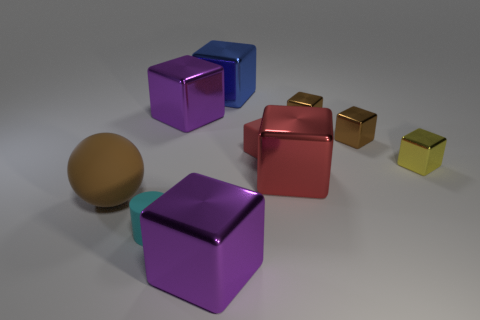What is the material of the large red thing that is the same shape as the blue object?
Give a very brief answer. Metal. What size is the metal block that is behind the large purple thing that is behind the small red thing?
Make the answer very short. Large. What material is the brown thing left of the tiny cylinder?
Keep it short and to the point. Rubber. There is a red thing that is the same material as the large blue block; what is its size?
Provide a short and direct response. Large. What number of tiny cyan matte things are the same shape as the yellow object?
Offer a very short reply. 0. There is a big blue metal object; is its shape the same as the big metal object that is in front of the large brown sphere?
Ensure brevity in your answer.  Yes. What shape is the object that is the same color as the small rubber cube?
Your response must be concise. Cube. Are there any large spheres made of the same material as the cylinder?
Provide a short and direct response. Yes. The tiny object that is on the left side of the purple block in front of the rubber sphere is made of what material?
Offer a terse response. Rubber. There is a purple metal object that is behind the large purple shiny cube that is in front of the small matte object that is in front of the big brown rubber object; how big is it?
Make the answer very short. Large. 